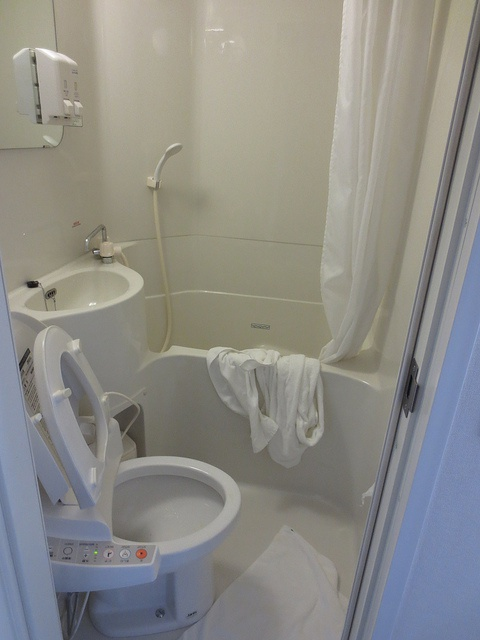Describe the objects in this image and their specific colors. I can see toilet in gray and darkgray tones and sink in gray and darkgray tones in this image. 